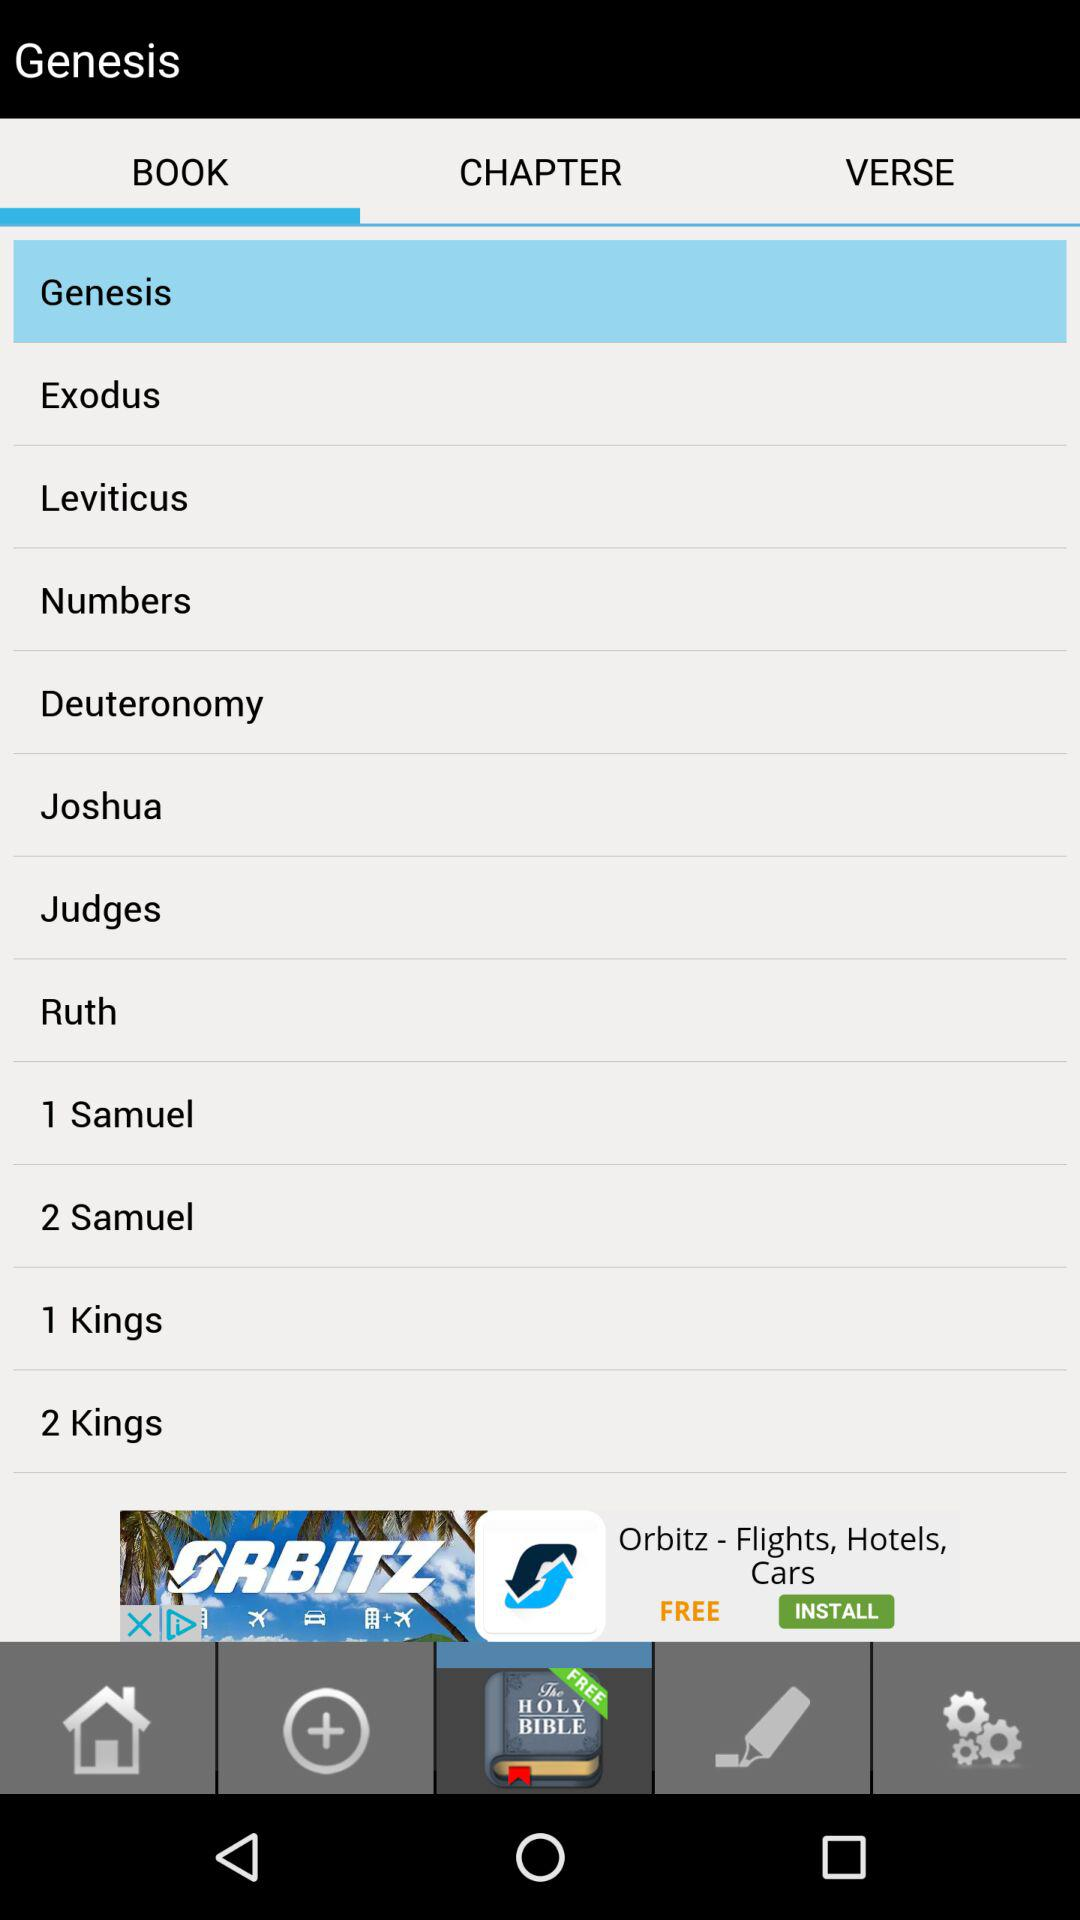Which tab is selected? The selected tab is "BOOK". 